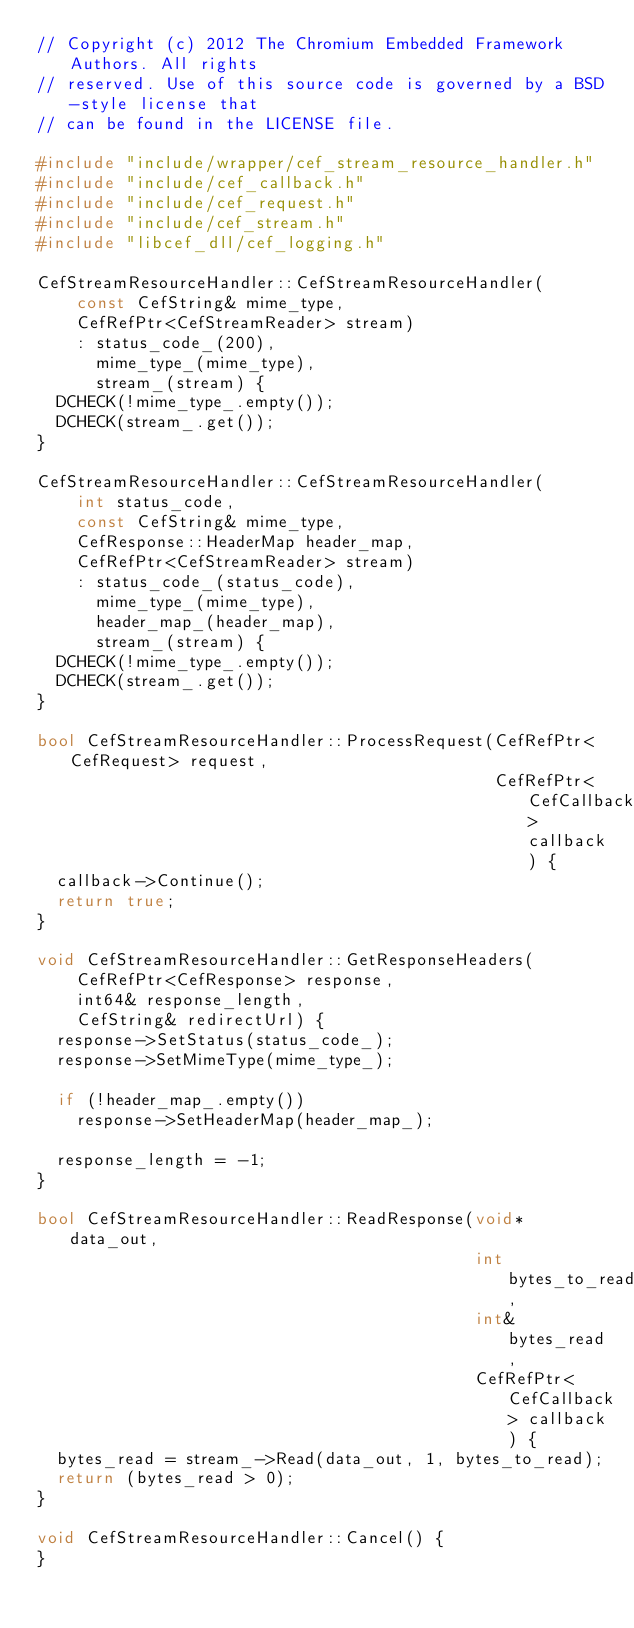<code> <loc_0><loc_0><loc_500><loc_500><_C++_>// Copyright (c) 2012 The Chromium Embedded Framework Authors. All rights
// reserved. Use of this source code is governed by a BSD-style license that
// can be found in the LICENSE file.

#include "include/wrapper/cef_stream_resource_handler.h"
#include "include/cef_callback.h"
#include "include/cef_request.h"
#include "include/cef_stream.h"
#include "libcef_dll/cef_logging.h"

CefStreamResourceHandler::CefStreamResourceHandler(
    const CefString& mime_type,
    CefRefPtr<CefStreamReader> stream)
    : status_code_(200),
      mime_type_(mime_type),
      stream_(stream) {
  DCHECK(!mime_type_.empty());
  DCHECK(stream_.get());
}

CefStreamResourceHandler::CefStreamResourceHandler(
    int status_code,
    const CefString& mime_type,
    CefResponse::HeaderMap header_map,
    CefRefPtr<CefStreamReader> stream)
    : status_code_(status_code),
      mime_type_(mime_type),
      header_map_(header_map),
      stream_(stream) {
  DCHECK(!mime_type_.empty());
  DCHECK(stream_.get());
}

bool CefStreamResourceHandler::ProcessRequest(CefRefPtr<CefRequest> request,
                                              CefRefPtr<CefCallback> callback) {
  callback->Continue();
  return true;
}

void CefStreamResourceHandler::GetResponseHeaders(
    CefRefPtr<CefResponse> response,
    int64& response_length,
    CefString& redirectUrl) {
  response->SetStatus(status_code_);
  response->SetMimeType(mime_type_);

  if (!header_map_.empty())
    response->SetHeaderMap(header_map_);

  response_length = -1;
}

bool CefStreamResourceHandler::ReadResponse(void* data_out,
                                            int bytes_to_read,
                                            int& bytes_read,
                                            CefRefPtr<CefCallback> callback) {
  bytes_read = stream_->Read(data_out, 1, bytes_to_read);
  return (bytes_read > 0);
}

void CefStreamResourceHandler::Cancel() {
}
</code> 